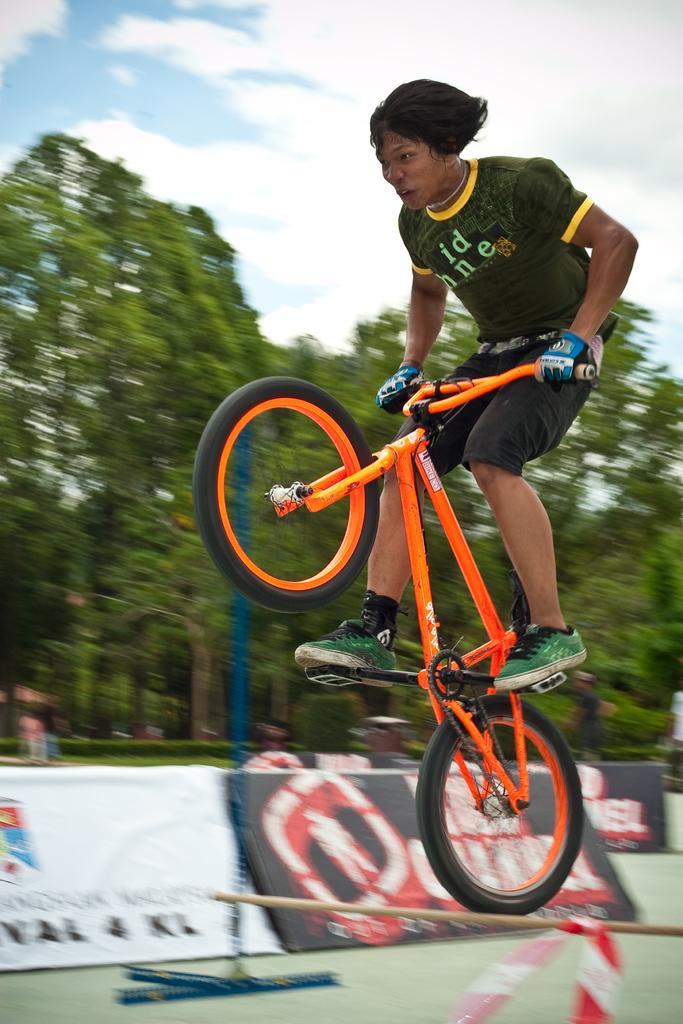How would you summarize this image in a sentence or two? In this image in front there is a person cycling on the wooden pole. Behind him there are banners. At the bottom of the image there is a mat. In the background of the image there are trees and sky. 